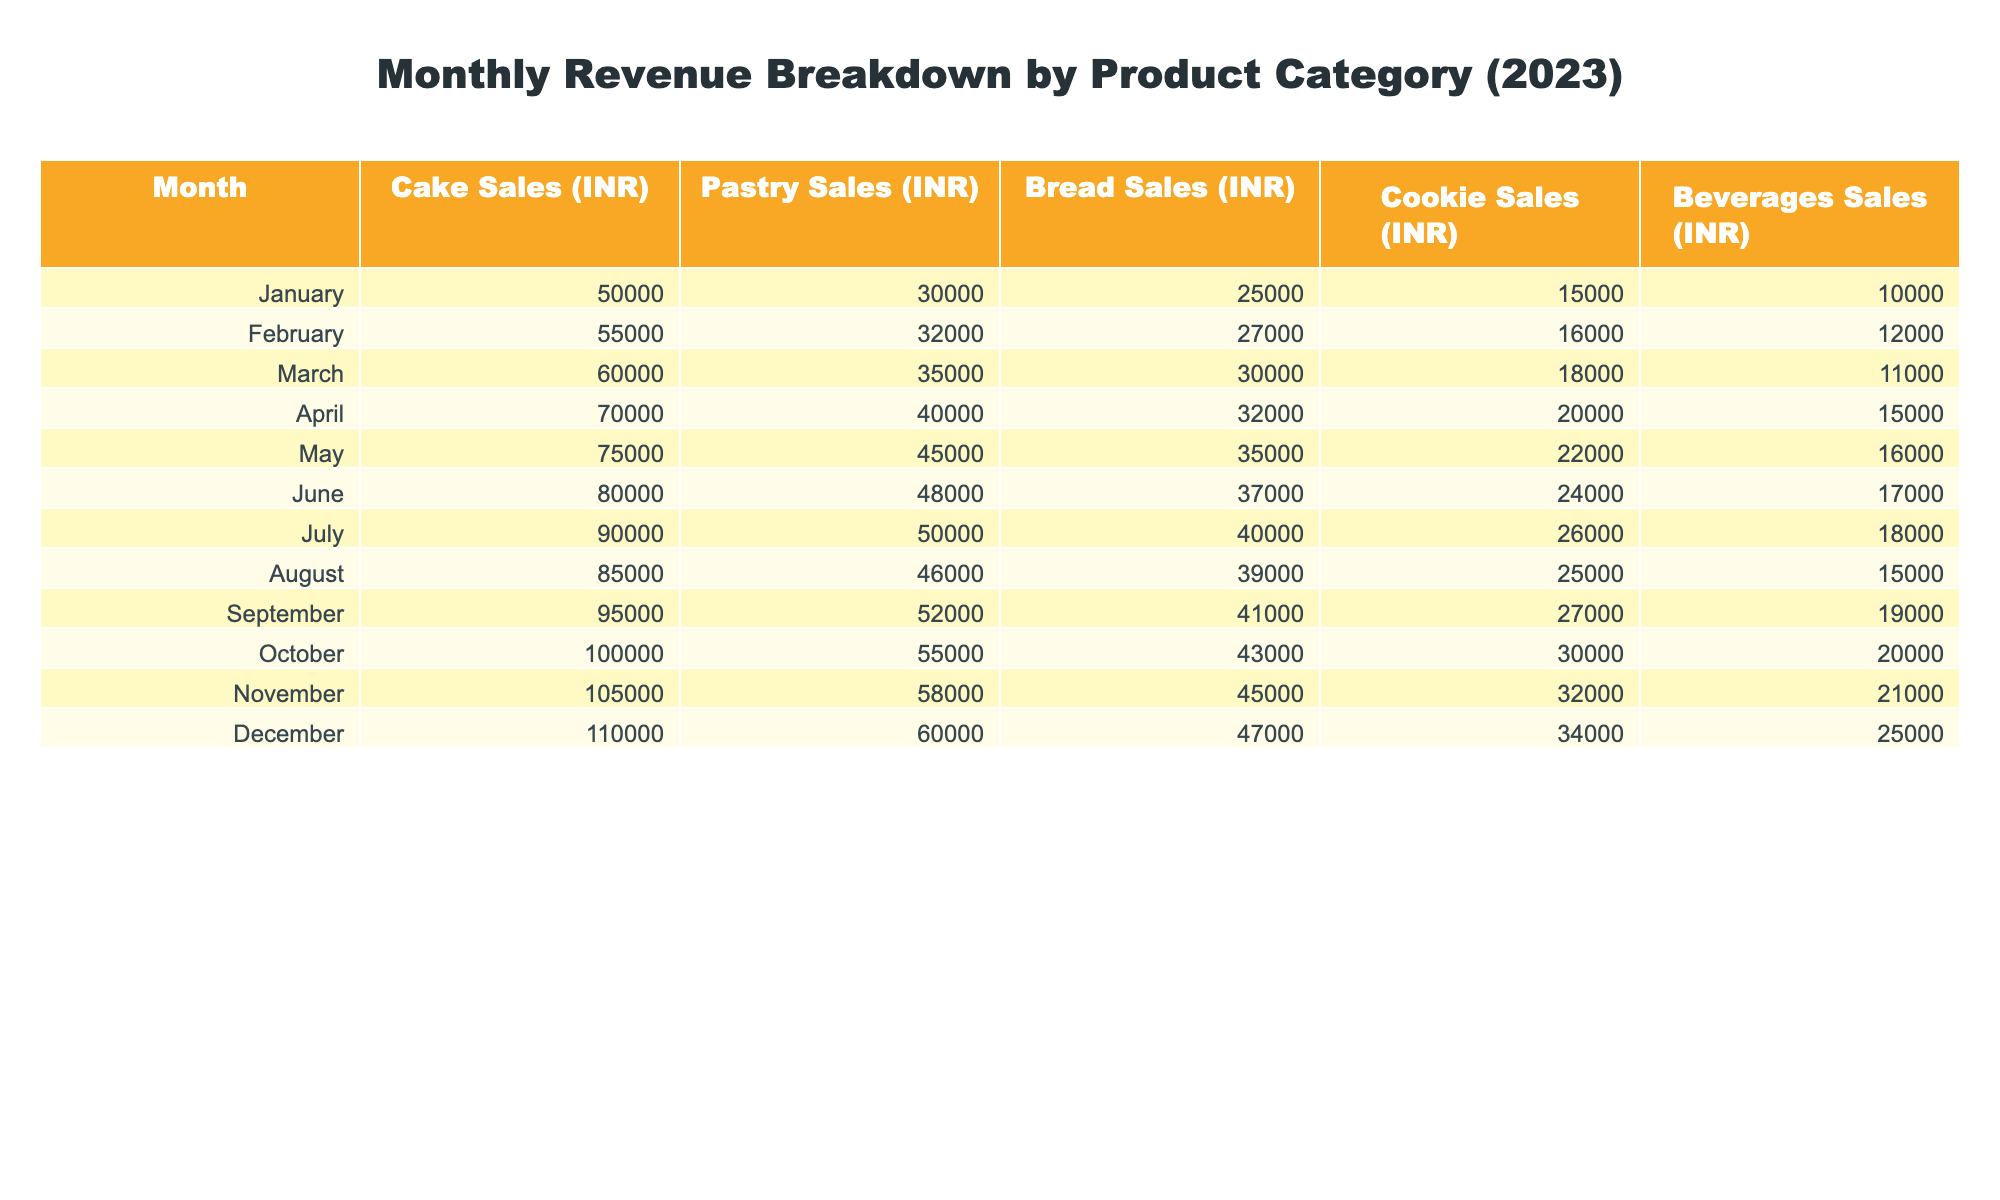What was the total revenue from cake sales in January? The table shows that cake sales in January amounted to 50,000 INR.
Answer: 50,000 INR Which product category had the highest sales in December? The table shows cake sales in December were 110,000 INR, more than any other category (pastries: 60,000 INR, bread: 47,000 INR, cookies: 34,000 INR, beverages: 25,000 INR).
Answer: Cake What was the average sales of pastries over the year? There are 12 months in the data. The total pastry sales for the year is (30,000 + 32,000 + 35,000 + 40,000 + 45,000 + 48,000 + 50,000 + 46,000 + 52,000 + 55,000 + 58,000 + 60,000) =  585,000 INR. Dividing this by 12 gives an average of 48,750 INR.
Answer: 48,750 INR Did bread sales ever exceed 40,000 INR? Yes, the table indicates that bread sales exceeded 40,000 INR starting in July (40,000 INR in July and increasing thereafter).
Answer: Yes What was the percentage increase in cookie sales from January to December? In January, cookie sales were 15,000 INR and in December they rose to 34,000 INR. The increase is 34,000 - 15,000 = 19,000 INR. The percentage increase is (19,000 / 15,000) * 100% = 126.67%.
Answer: 126.67% Which month had the least revenue from beverages? The table shows that the lowest beverage sales were in January with 10,000 INR compared to other months.
Answer: January What were the total revenues from all categories for the month of October? The table lists totals for October: Cake: 100,000 INR, Pastry: 55,000 INR, Bread: 43,000 INR, Cookies: 30,000 INR, Beverages: 20,000 INR. The total is 100,000 + 55,000 + 43,000 + 30,000 + 20,000 = 348,000 INR.
Answer: 348,000 INR Which product category experienced the largest growth in sales throughout the year? The maximum sales increase was in cake sales, increasing from 50,000 INR in January to 110,000 INR in December. The increase amounts to 60,000 INR.
Answer: Cake What was the revenue from beverage sales in the first half of the year (January to June)? For the first half of the year, the beverage sales were: January 10,000 INR, February 12,000 INR, March 11,000 INR, April 15,000 INR, May 16,000 INR, June 17,000 INR. The total is 10,000 + 12,000 + 11,000 + 15,000 + 16,000 + 17,000 = 81,000 INR.
Answer: 81,000 INR Was there any month where pastry sales dropped compared to the previous month? Looking at the table, pastry sales did not drop at any point; it consistently increased from January to December.
Answer: No 